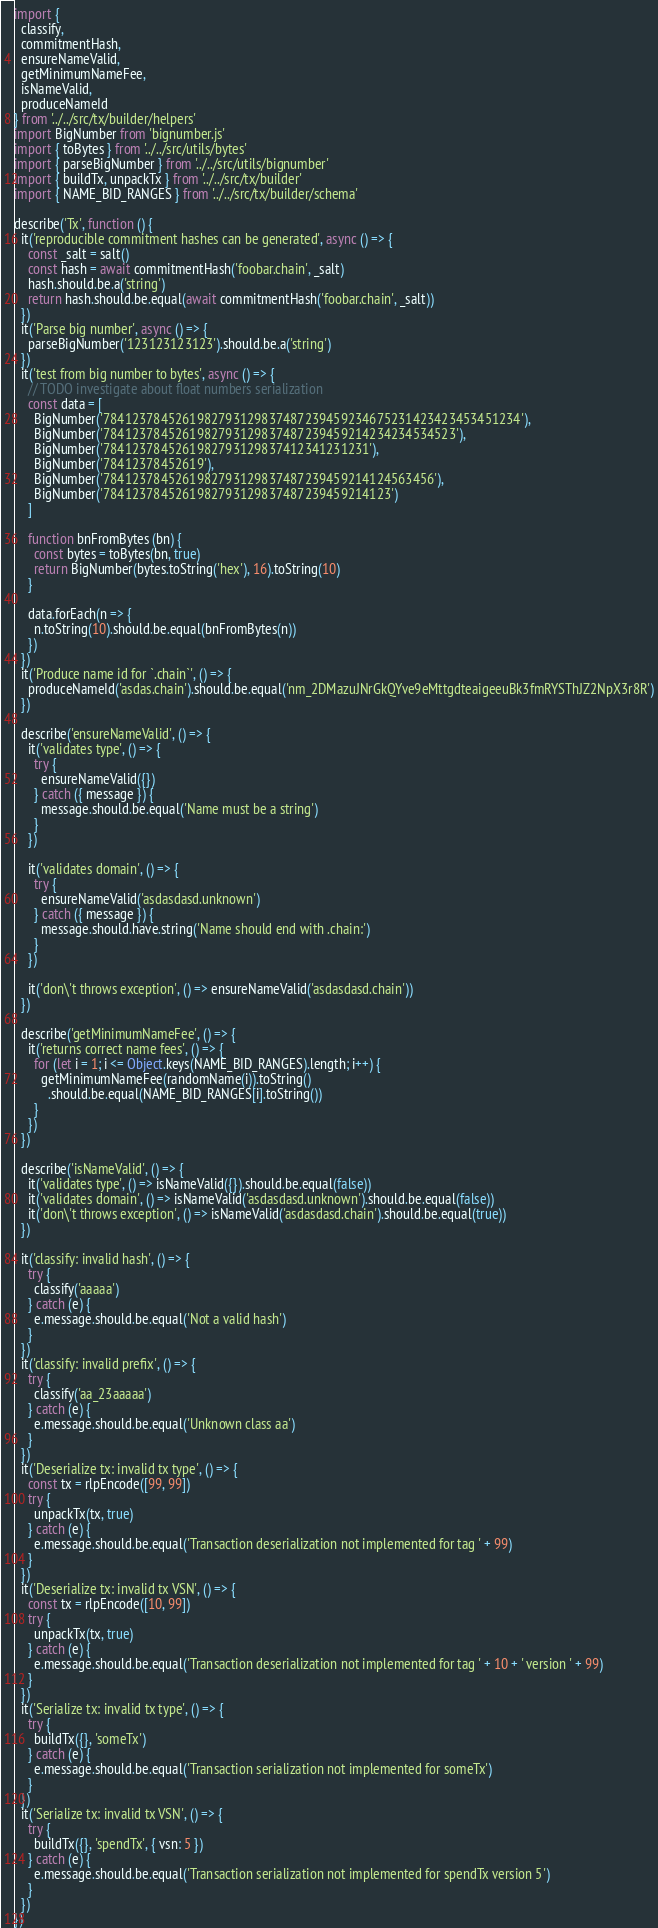<code> <loc_0><loc_0><loc_500><loc_500><_JavaScript_>import {
  classify,
  commitmentHash,
  ensureNameValid,
  getMinimumNameFee,
  isNameValid,
  produceNameId
} from '../../src/tx/builder/helpers'
import BigNumber from 'bignumber.js'
import { toBytes } from '../../src/utils/bytes'
import { parseBigNumber } from '../../src/utils/bignumber'
import { buildTx, unpackTx } from '../../src/tx/builder'
import { NAME_BID_RANGES } from '../../src/tx/builder/schema'

describe('Tx', function () {
  it('reproducible commitment hashes can be generated', async () => {
    const _salt = salt()
    const hash = await commitmentHash('foobar.chain', _salt)
    hash.should.be.a('string')
    return hash.should.be.equal(await commitmentHash('foobar.chain', _salt))
  })
  it('Parse big number', async () => {
    parseBigNumber('123123123123').should.be.a('string')
  })
  it('test from big number to bytes', async () => {
    // TODO investigate about float numbers serialization
    const data = [
      BigNumber('7841237845261982793129837487239459234675231423423453451234'),
      BigNumber('7841237845261982793129837487239459214234234534523'),
      BigNumber('7841237845261982793129837412341231231'),
      BigNumber('78412378452619'),
      BigNumber('7841237845261982793129837487239459214124563456'),
      BigNumber('7841237845261982793129837487239459214123')
    ]

    function bnFromBytes (bn) {
      const bytes = toBytes(bn, true)
      return BigNumber(bytes.toString('hex'), 16).toString(10)
    }

    data.forEach(n => {
      n.toString(10).should.be.equal(bnFromBytes(n))
    })
  })
  it('Produce name id for `.chain`', () => {
    produceNameId('asdas.chain').should.be.equal('nm_2DMazuJNrGkQYve9eMttgdteaigeeuBk3fmRYSThJZ2NpX3r8R')
  })

  describe('ensureNameValid', () => {
    it('validates type', () => {
      try {
        ensureNameValid({})
      } catch ({ message }) {
        message.should.be.equal('Name must be a string')
      }
    })

    it('validates domain', () => {
      try {
        ensureNameValid('asdasdasd.unknown')
      } catch ({ message }) {
        message.should.have.string('Name should end with .chain:')
      }
    })

    it('don\'t throws exception', () => ensureNameValid('asdasdasd.chain'))
  })

  describe('getMinimumNameFee', () => {
    it('returns correct name fees', () => {
      for (let i = 1; i <= Object.keys(NAME_BID_RANGES).length; i++) {
        getMinimumNameFee(randomName(i)).toString()
          .should.be.equal(NAME_BID_RANGES[i].toString())
      }
    })
  })

  describe('isNameValid', () => {
    it('validates type', () => isNameValid({}).should.be.equal(false))
    it('validates domain', () => isNameValid('asdasdasd.unknown').should.be.equal(false))
    it('don\'t throws exception', () => isNameValid('asdasdasd.chain').should.be.equal(true))
  })

  it('classify: invalid hash', () => {
    try {
      classify('aaaaa')
    } catch (e) {
      e.message.should.be.equal('Not a valid hash')
    }
  })
  it('classify: invalid prefix', () => {
    try {
      classify('aa_23aaaaa')
    } catch (e) {
      e.message.should.be.equal('Unknown class aa')
    }
  })
  it('Deserialize tx: invalid tx type', () => {
    const tx = rlpEncode([99, 99])
    try {
      unpackTx(tx, true)
    } catch (e) {
      e.message.should.be.equal('Transaction deserialization not implemented for tag ' + 99)
    }
  })
  it('Deserialize tx: invalid tx VSN', () => {
    const tx = rlpEncode([10, 99])
    try {
      unpackTx(tx, true)
    } catch (e) {
      e.message.should.be.equal('Transaction deserialization not implemented for tag ' + 10 + ' version ' + 99)
    }
  })
  it('Serialize tx: invalid tx type', () => {
    try {
      buildTx({}, 'someTx')
    } catch (e) {
      e.message.should.be.equal('Transaction serialization not implemented for someTx')
    }
  })
  it('Serialize tx: invalid tx VSN', () => {
    try {
      buildTx({}, 'spendTx', { vsn: 5 })
    } catch (e) {
      e.message.should.be.equal('Transaction serialization not implemented for spendTx version 5')
    }
  })
})
</code> 